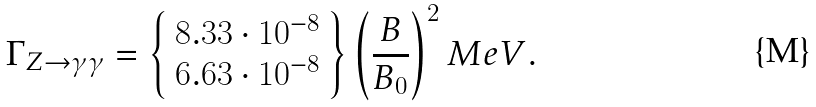<formula> <loc_0><loc_0><loc_500><loc_500>\Gamma _ { Z \rightarrow \gamma \gamma } = \left \{ \begin{array} { c } 8 . 3 3 \cdot 1 0 ^ { - 8 } \\ 6 . 6 3 \cdot 1 0 ^ { - 8 } \end{array} \right \} \left ( \frac { B } { B _ { 0 } } \right ) ^ { 2 } M e V .</formula> 